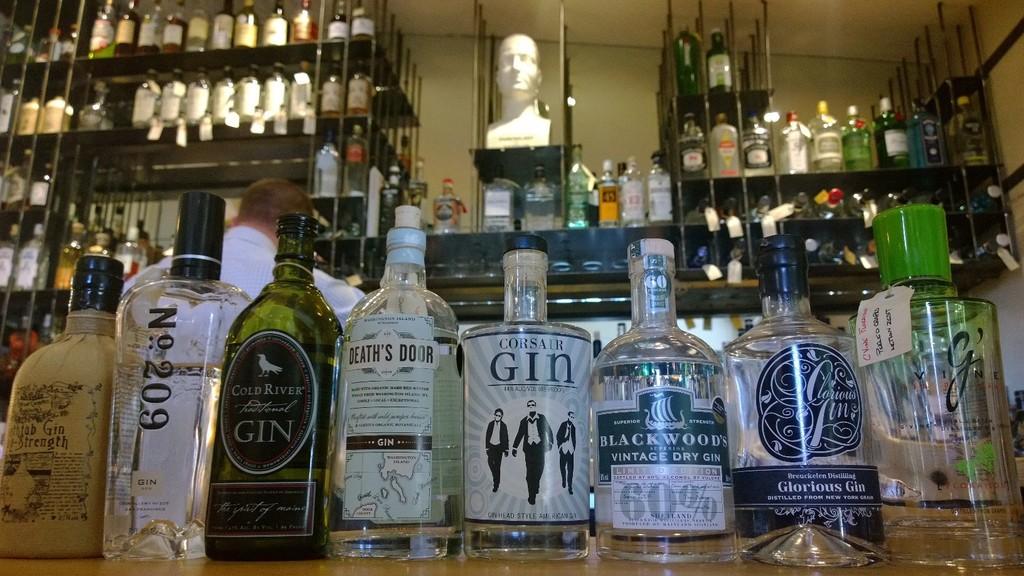All of the bottles appear to be what type of liquor?
Offer a terse response. Gin. What kind of liquor are these bottles?
Give a very brief answer. Gin. 